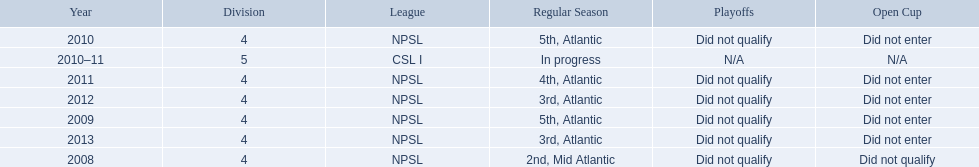What are the names of the leagues? NPSL, CSL I. Which league other than npsl did ny soccer team play under? CSL I. 